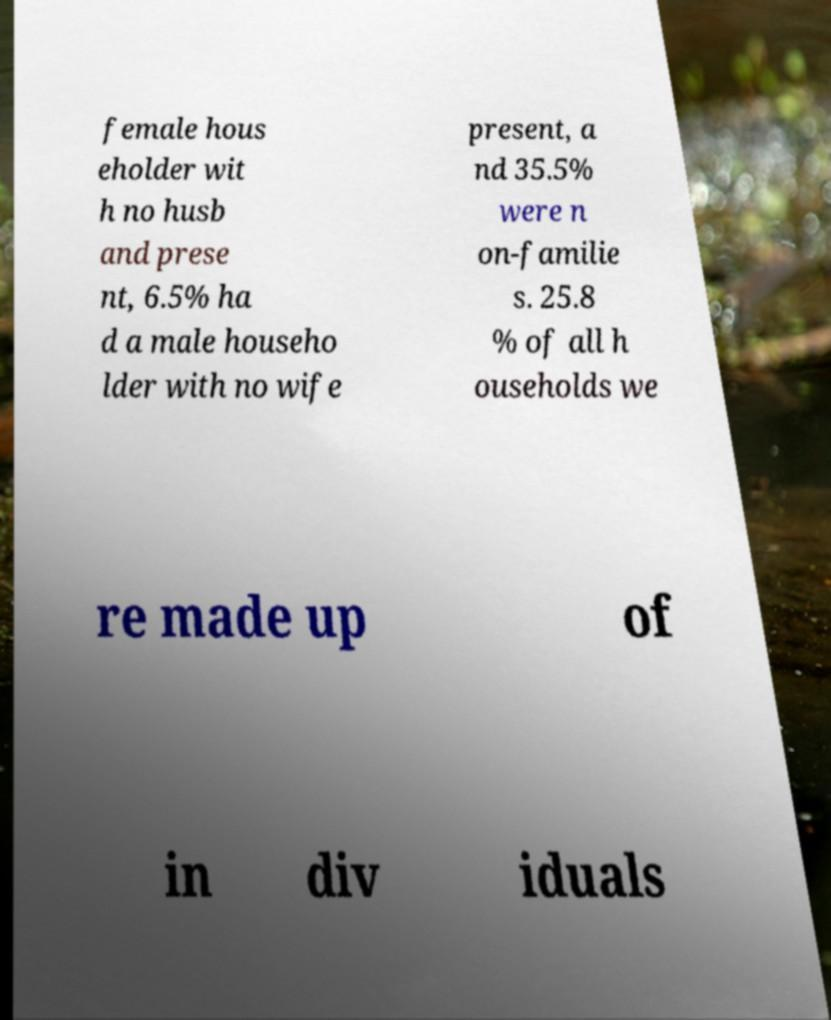What messages or text are displayed in this image? I need them in a readable, typed format. female hous eholder wit h no husb and prese nt, 6.5% ha d a male househo lder with no wife present, a nd 35.5% were n on-familie s. 25.8 % of all h ouseholds we re made up of in div iduals 